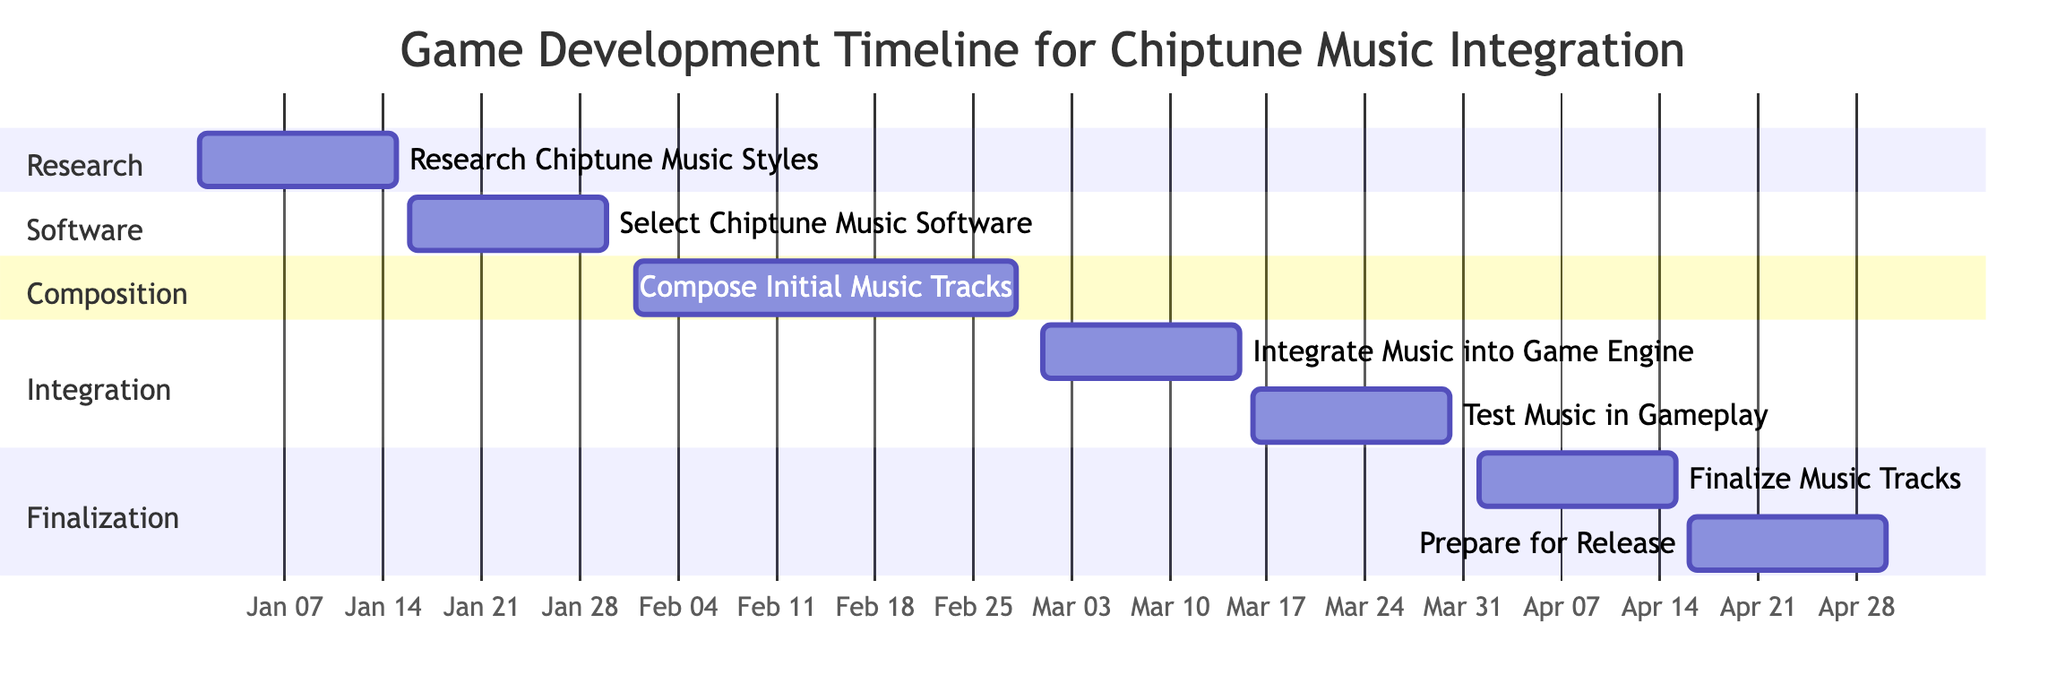What is the duration of the "Compose Initial Music Tracks" task? The "Compose Initial Music Tracks" task starts on February 1, 2024, and ends on February 28, 2024. To find the duration, you count the days from the start date to the end date, which is a total of 28 days.
Answer: 28 days Which task directly follows "Select Chiptune Music Software"? After the "Select Chiptune Music Software" task, the next task is "Compose Initial Music Tracks." This is determined by looking at the dates and task order in the timeline.
Answer: Compose Initial Music Tracks How many tasks are scheduled for March 2024? In March 2024, there are two tasks: "Integrate Music into Game Engine" and "Test Music in Gameplay." By examining the timeline and counting the tasks specifically designated for March, we find two tasks listed for that month.
Answer: 2 tasks What is the end date for the "Prepare for Release" task? The "Prepare for Release" task ends on April 30, 2024. This can be verified by looking at the timestamp for that specific task on the Gantt chart.
Answer: April 30, 2024 Which section includes the task "Finalize Music Tracks"? The "Finalize Music Tracks" task is included in the "Finalization" section. This is determined by the organization of tasks into sections visible in the Gantt chart.
Answer: Finalization 